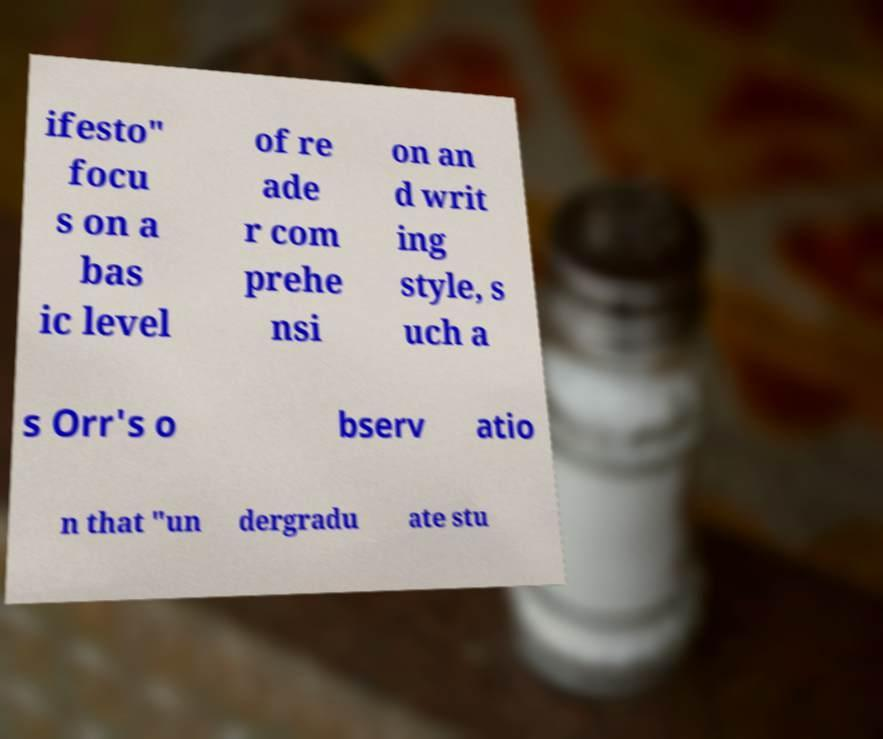Can you accurately transcribe the text from the provided image for me? ifesto" focu s on a bas ic level of re ade r com prehe nsi on an d writ ing style, s uch a s Orr's o bserv atio n that "un dergradu ate stu 